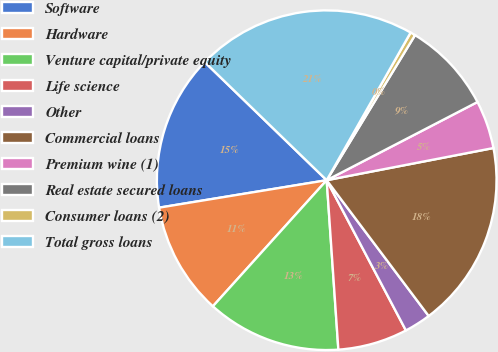Convert chart to OTSL. <chart><loc_0><loc_0><loc_500><loc_500><pie_chart><fcel>Software<fcel>Hardware<fcel>Venture capital/private equity<fcel>Life science<fcel>Other<fcel>Commercial loans<fcel>Premium wine (1)<fcel>Real estate secured loans<fcel>Consumer loans (2)<fcel>Total gross loans<nl><fcel>14.83%<fcel>10.73%<fcel>12.78%<fcel>6.63%<fcel>2.53%<fcel>17.78%<fcel>4.58%<fcel>8.68%<fcel>0.48%<fcel>20.98%<nl></chart> 